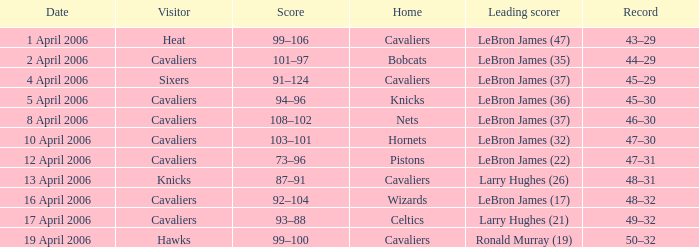What day was the game that had the Cavaliers as visiting team and the Knicks as the home team? 5 April 2006. 